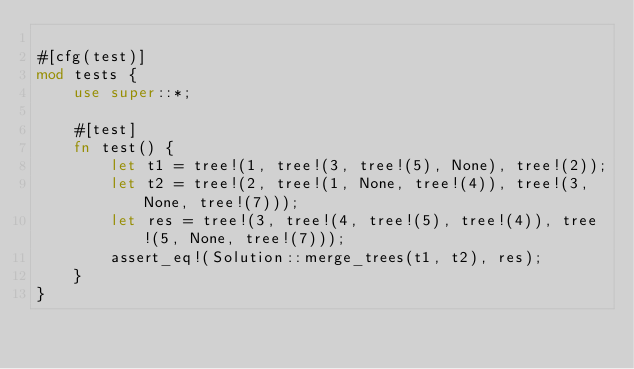Convert code to text. <code><loc_0><loc_0><loc_500><loc_500><_Rust_>
#[cfg(test)]
mod tests {
    use super::*;

    #[test]
    fn test() {
        let t1 = tree!(1, tree!(3, tree!(5), None), tree!(2));
        let t2 = tree!(2, tree!(1, None, tree!(4)), tree!(3, None, tree!(7)));
        let res = tree!(3, tree!(4, tree!(5), tree!(4)), tree!(5, None, tree!(7)));
        assert_eq!(Solution::merge_trees(t1, t2), res);
    }
}
</code> 